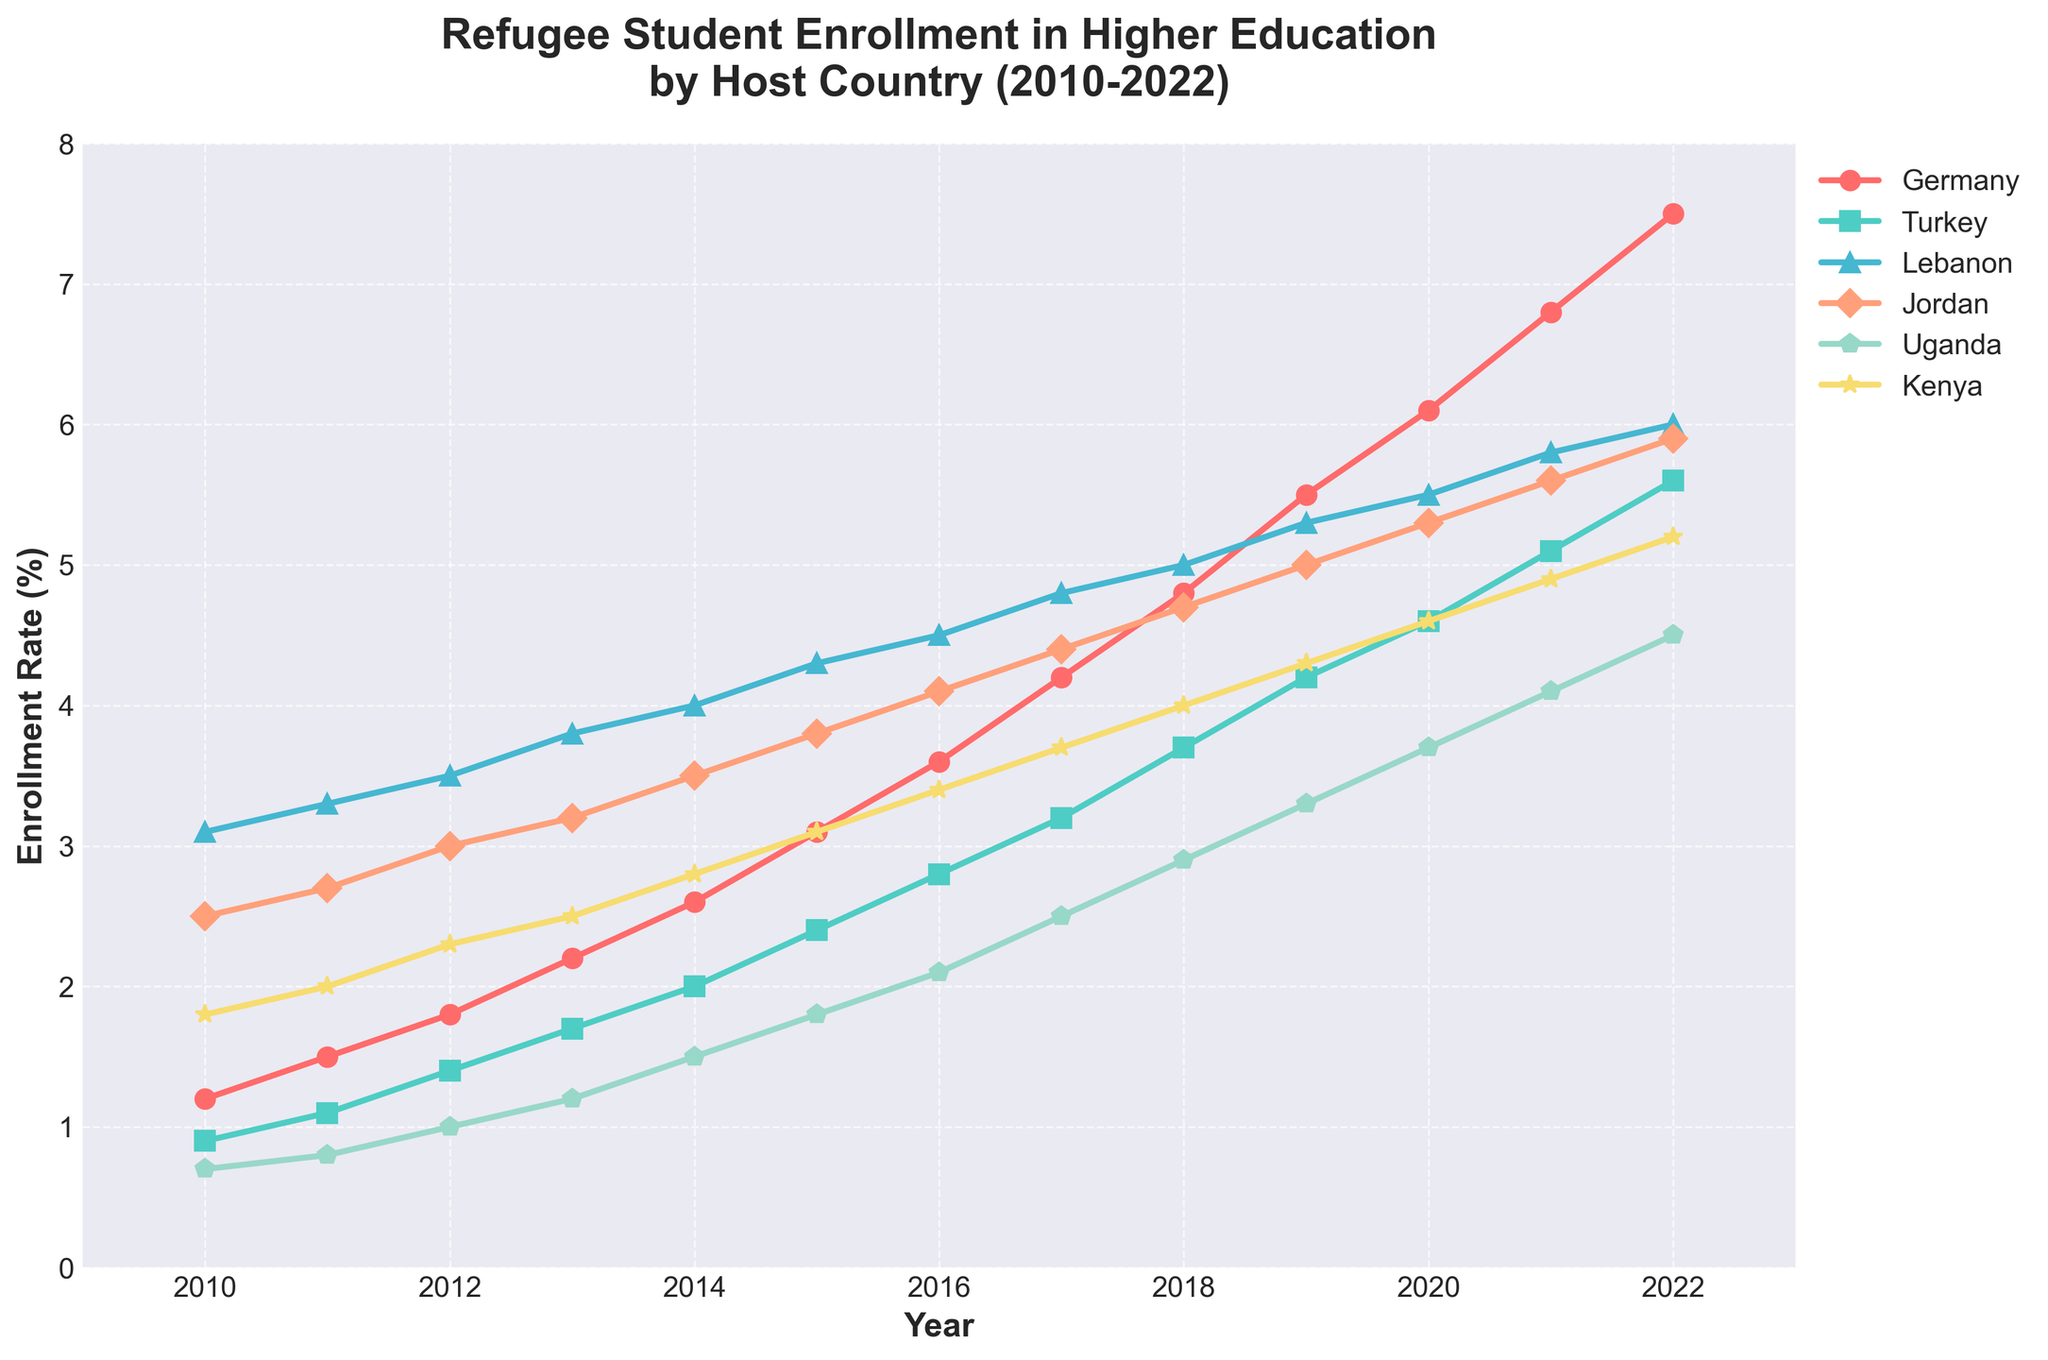Which country had the highest enrollment rate in 2022? To find the highest enrollment rate in 2022, look at the values for each country in the year 2022. The highest value is 7.5% for Germany.
Answer: Germany Between 2010 and 2014, which country showed the most consistent increase in enrollment rates? Consistency can be inferred from the smoothness and uniformity of the increase in enrollment rate over the years. Jordan shows a smooth, uniform increase from 2.5% in 2010 to 3.5% in 2014.
Answer: Jordan What is the difference in the enrollment rates of Germany from 2010 to 2022? Subtract the enrollment rate of Germany in 2010 from the enrollment rate in 2022. Specifically: 7.5% (2022) - 1.2% (2010) = 6.3%.
Answer: 6.3% Which country experienced the greatest overall increase in enrollment rates from 2010 to 2022? Look at the enrollment rates in 2010 and 2022 for each country. Calculate the difference for each. Germany's increase is 7.5% - 1.2% = 6.3%, Turkey's is 5.6% - 0.9% = 4.7%, etc. Germany had the greatest increase of 6.3%.
Answer: Germany What is the average enrollment rate for Turkey between 2010 and 2022? Add all of Turkey's enrollment rates from 2010 to 2022 and divide by the number of years (13). This is: (0.9 + 1.1 + 1.4 + 1.7 + 2.0 + 2.4 + 2.8 + 3.2 + 3.7 + 4.2 + 4.6 + 5.1 + 5.6) / 13 = 3.23% (rounded).
Answer: 3.23% Which two countries had equal enrollment rates in any year? By inspecting the values, Kenya and Jordan had equal enrollment rates of 5.3% in 2020.
Answer: Kenya and Jordan How did the enrollment rates in Lebanon change from 2012 to 2014? Look at Lebanon's values from 2012 to 2014: 3.5% (2012), 3.8% (2013), 4.0% (2014). Lebanon's rate increased yearly over this period.
Answer: Increased By how much did Uganda's enrollment rate increase from 2016 to 2019? Subtract Uganda's rate in 2016 from its rate in 2019: 3.3% - 2.1% = 1.2%.
Answer: 1.2% Which country had the lowest enrollment rate in 2021? Compare the enrollment rates of all countries for the year 2021. Uganda had the lowest rate at 4.1%.
Answer: Uganda Did any country experience a decrease in enrollment rates between any two consecutive years? By analyzing the data, no country shows a decrease in enrollment rates between any two consecutive years from 2010 to 2022.
Answer: No 